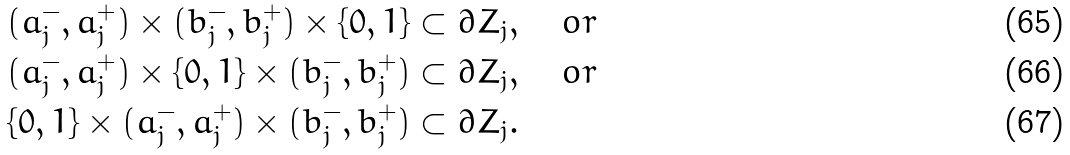<formula> <loc_0><loc_0><loc_500><loc_500>& ( a _ { j } ^ { - } , a _ { j } ^ { + } ) \times ( b _ { j } ^ { - } , b _ { j } ^ { + } ) \times \{ 0 , 1 \} \subset \partial Z _ { j } , \quad o r \\ & ( a _ { j } ^ { - } , a _ { j } ^ { + } ) \times \{ 0 , 1 \} \times ( b _ { j } ^ { - } , b _ { j } ^ { + } ) \subset \partial Z _ { j } , \quad o r \\ & \{ 0 , 1 \} \times ( a _ { j } ^ { - } , a _ { j } ^ { + } ) \times ( b _ { j } ^ { - } , b _ { j } ^ { + } ) \subset \partial Z _ { j } .</formula> 